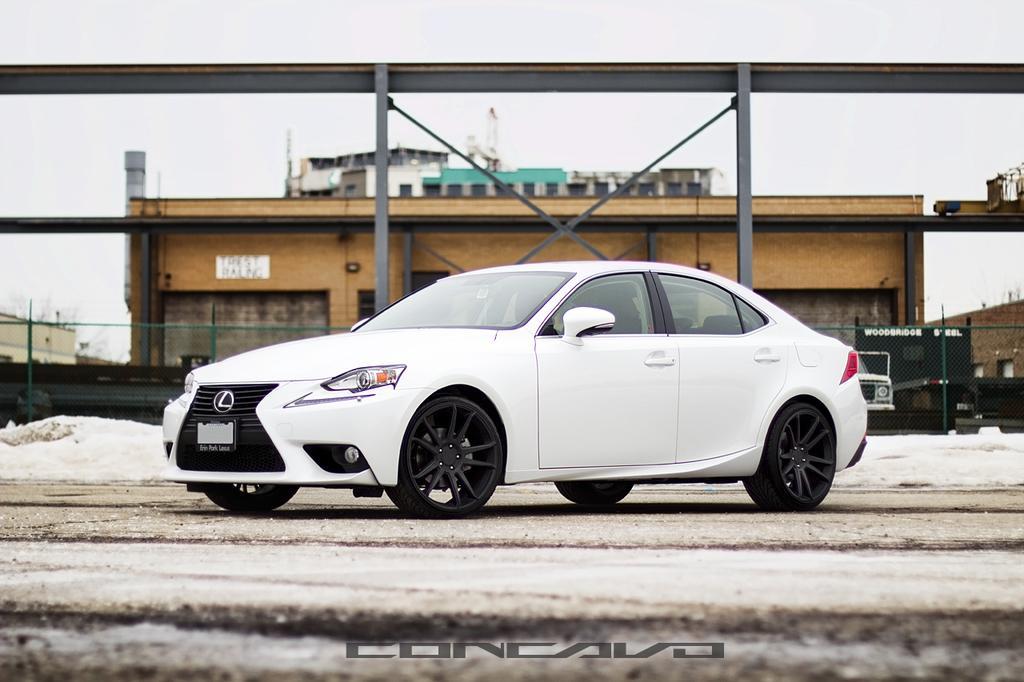Can you describe this image briefly? In this picture I can see vehicles, there is snow, there is fence, there are buildings, and in the background there is the sky and there is a watermark on the image. 